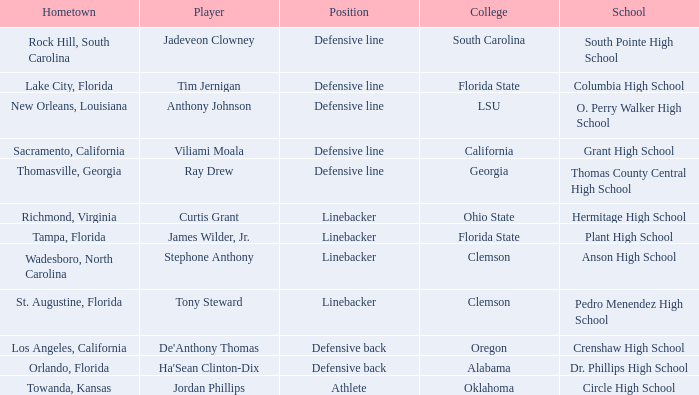Which player is from Tampa, Florida? James Wilder, Jr. 